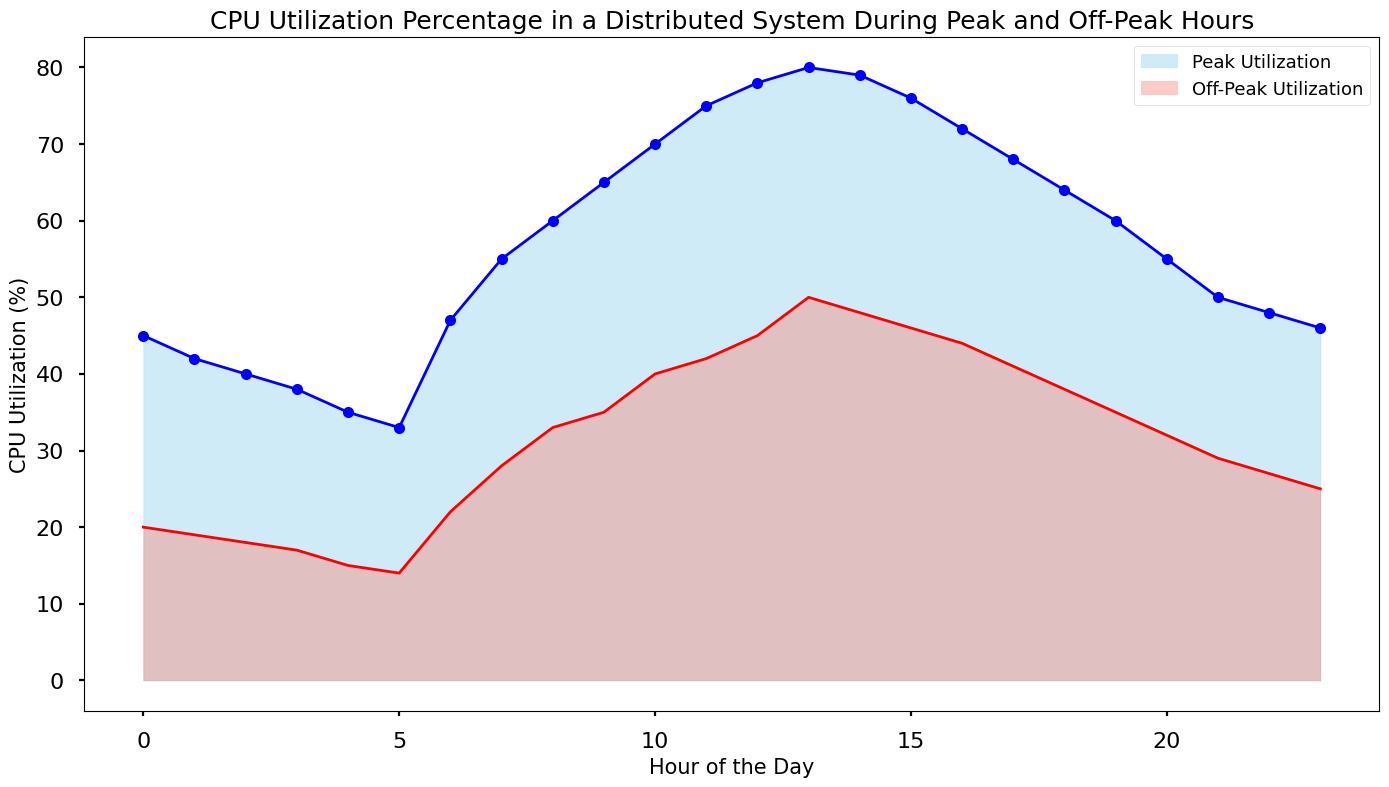What is the peak CPU utilization at noon? By referring to the figure, look for the 'hour' corresponding to 12 and check the CPU utilization under the 'peak_cpu_utilization' line.
Answer: 78% During which hour is the off-peak CPU utilization the lowest? Identify the 'hour' where the 'off_peak_cpu_utilization' line hits its minimum value by visually scanning the chart.
Answer: 5 Compare the peak and off-peak CPU utilizations at 9 AM. Which is higher and by how much? At the 9th hour mark, find the values for both 'peak_cpu_utilization' and 'off_peak_cpu_utilization'. Peak is 65%, off-peak is 35%. Subtract the off-peak value from the peak value (65 - 35).
Answer: Peak is higher by 30% How do the peak and off-peak CPU utilizations generally differ between 12 PM and 6 PM? Visually compare the trends of the two lines between the hours of 12 and 18. The peak utilization fluctuates between 78% and 64%, while off-peak moves between 45% and 38%.
Answer: Peak is higher, declining from 78% to 64%; off-peak also declines from 45% to 38% What is the average off-peak CPU utilization across the entire day? Sum all off-peak utilization values and divide by the number of hours (24). Sum = 18+17+15+14+22+28+33+35+40+42+45+50+48+46+44+41+38+35+32+29+27+25 = 716. Average = 716 / 24.
Answer: 29.83% Which hour shows the largest difference between peak and off-peak CPU utilization? Calculate the difference between peak and off-peak utilizations for each hour and identify the maximum difference. For instance, at 12: (78 - 45 = 33), etc. Identify the hour with the largest result.
Answer: 13 (difference of 30) At what time(s) do the peak and off-peak CPU utilizations start declining? Look for the hour where the peak and off-peak utilization lines reverse from increasing to decreasing. For peak, this starts right after 13th hour, and for off-peak, it is around the 14th hour.
Answer: Peak starts declining at 13, off-peak at 14 How much does the peak CPU utilization increase from 5 AM to 6 AM? Find the difference in 'peak_cpu_utilization' between hours 5 and 6. Peak at 5 AM is 33%, and at 6 AM it is 47%. (47 - 33).
Answer: 14% What visual differences can you observe between the peak and off-peak utilization areas on the chart? Identify the color, height, and spread of the areas representing peak and off-peak utilizations on the chart. Peak utilization is represented in light blue, while off-peak is salmon. The blue area is generally taller and larger in spread compared to the salmon area.
Answer: Peak is light blue and larger; off-peak is salmon and smaller Why does the CPU utilization line change more sharply during peak hours compared to off-peak hours? Observe the line representing peak utilization; it shows larger fluctuations, indicating more dynamic and variable CPU usage during peak times (due to higher system demand). The off-peak line is smoother, reflecting more consistent lower usage.
Answer: More dynamic usage during peak hours 